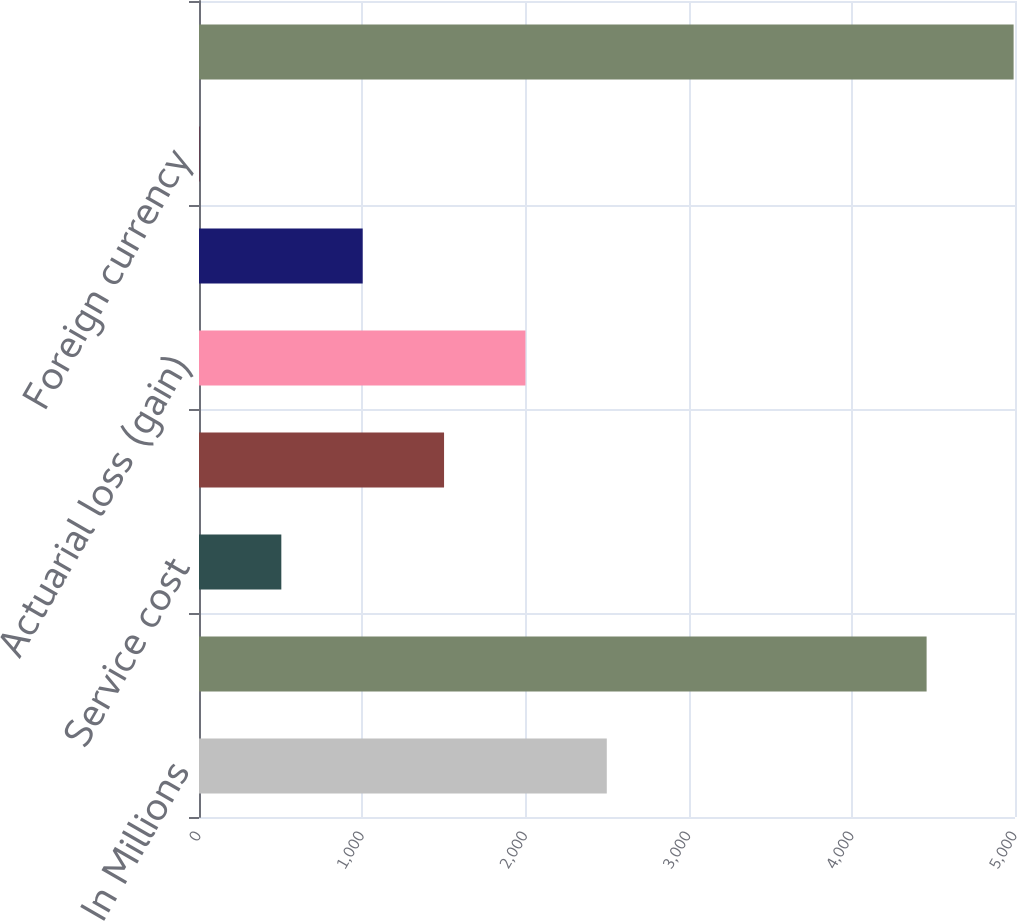Convert chart to OTSL. <chart><loc_0><loc_0><loc_500><loc_500><bar_chart><fcel>In Millions<fcel>Benefit obligation at<fcel>Service cost<fcel>Interest cost<fcel>Actuarial loss (gain)<fcel>Benefits payments<fcel>Foreign currency<fcel>Projected benefit obligation<nl><fcel>2498.7<fcel>4458.4<fcel>504.46<fcel>1501.58<fcel>2000.14<fcel>1003.02<fcel>5.9<fcel>4991.5<nl></chart> 